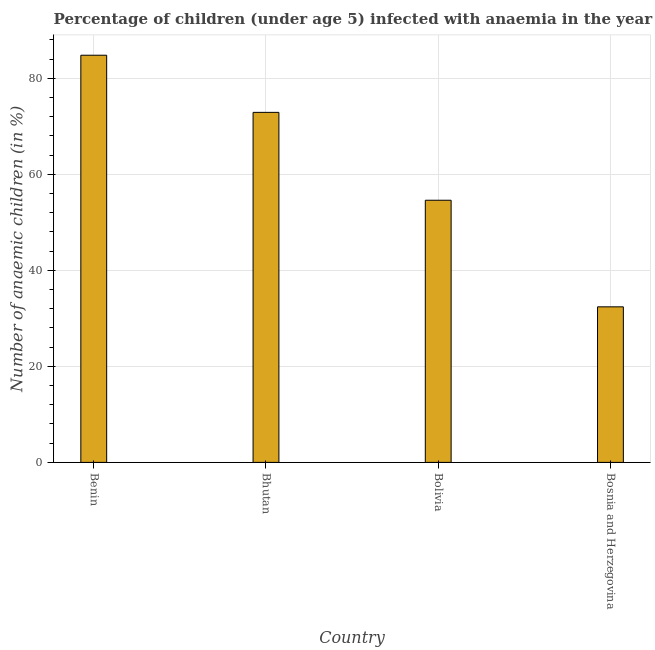Does the graph contain any zero values?
Your answer should be very brief. No. Does the graph contain grids?
Provide a succinct answer. Yes. What is the title of the graph?
Your response must be concise. Percentage of children (under age 5) infected with anaemia in the year 1994. What is the label or title of the Y-axis?
Your response must be concise. Number of anaemic children (in %). What is the number of anaemic children in Bolivia?
Offer a very short reply. 54.6. Across all countries, what is the maximum number of anaemic children?
Offer a very short reply. 84.8. Across all countries, what is the minimum number of anaemic children?
Provide a succinct answer. 32.4. In which country was the number of anaemic children maximum?
Your answer should be compact. Benin. In which country was the number of anaemic children minimum?
Your answer should be very brief. Bosnia and Herzegovina. What is the sum of the number of anaemic children?
Give a very brief answer. 244.7. What is the average number of anaemic children per country?
Offer a very short reply. 61.17. What is the median number of anaemic children?
Ensure brevity in your answer.  63.75. In how many countries, is the number of anaemic children greater than 8 %?
Ensure brevity in your answer.  4. What is the ratio of the number of anaemic children in Benin to that in Bosnia and Herzegovina?
Keep it short and to the point. 2.62. Is the number of anaemic children in Bhutan less than that in Bosnia and Herzegovina?
Offer a very short reply. No. What is the difference between the highest and the second highest number of anaemic children?
Provide a succinct answer. 11.9. What is the difference between the highest and the lowest number of anaemic children?
Offer a very short reply. 52.4. In how many countries, is the number of anaemic children greater than the average number of anaemic children taken over all countries?
Ensure brevity in your answer.  2. What is the Number of anaemic children (in %) in Benin?
Offer a very short reply. 84.8. What is the Number of anaemic children (in %) in Bhutan?
Ensure brevity in your answer.  72.9. What is the Number of anaemic children (in %) in Bolivia?
Your answer should be very brief. 54.6. What is the Number of anaemic children (in %) of Bosnia and Herzegovina?
Your answer should be very brief. 32.4. What is the difference between the Number of anaemic children (in %) in Benin and Bhutan?
Provide a short and direct response. 11.9. What is the difference between the Number of anaemic children (in %) in Benin and Bolivia?
Provide a short and direct response. 30.2. What is the difference between the Number of anaemic children (in %) in Benin and Bosnia and Herzegovina?
Your answer should be compact. 52.4. What is the difference between the Number of anaemic children (in %) in Bhutan and Bosnia and Herzegovina?
Your answer should be compact. 40.5. What is the ratio of the Number of anaemic children (in %) in Benin to that in Bhutan?
Ensure brevity in your answer.  1.16. What is the ratio of the Number of anaemic children (in %) in Benin to that in Bolivia?
Your answer should be very brief. 1.55. What is the ratio of the Number of anaemic children (in %) in Benin to that in Bosnia and Herzegovina?
Provide a short and direct response. 2.62. What is the ratio of the Number of anaemic children (in %) in Bhutan to that in Bolivia?
Your answer should be compact. 1.33. What is the ratio of the Number of anaemic children (in %) in Bhutan to that in Bosnia and Herzegovina?
Offer a very short reply. 2.25. What is the ratio of the Number of anaemic children (in %) in Bolivia to that in Bosnia and Herzegovina?
Give a very brief answer. 1.69. 